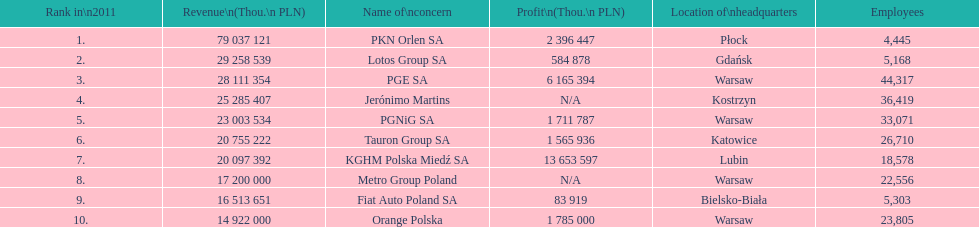Which company had the most revenue? PKN Orlen SA. 